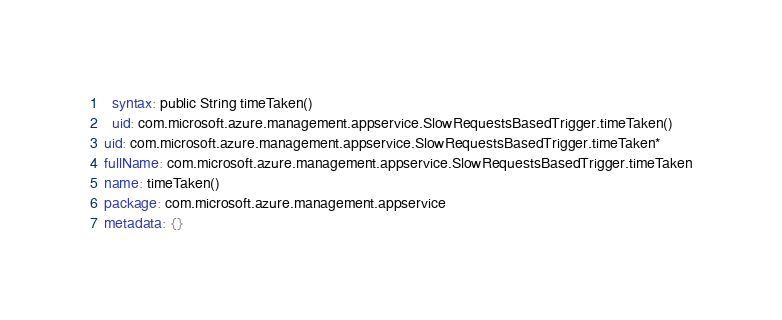<code> <loc_0><loc_0><loc_500><loc_500><_YAML_>  syntax: public String timeTaken()
  uid: com.microsoft.azure.management.appservice.SlowRequestsBasedTrigger.timeTaken()
uid: com.microsoft.azure.management.appservice.SlowRequestsBasedTrigger.timeTaken*
fullName: com.microsoft.azure.management.appservice.SlowRequestsBasedTrigger.timeTaken
name: timeTaken()
package: com.microsoft.azure.management.appservice
metadata: {}
</code> 